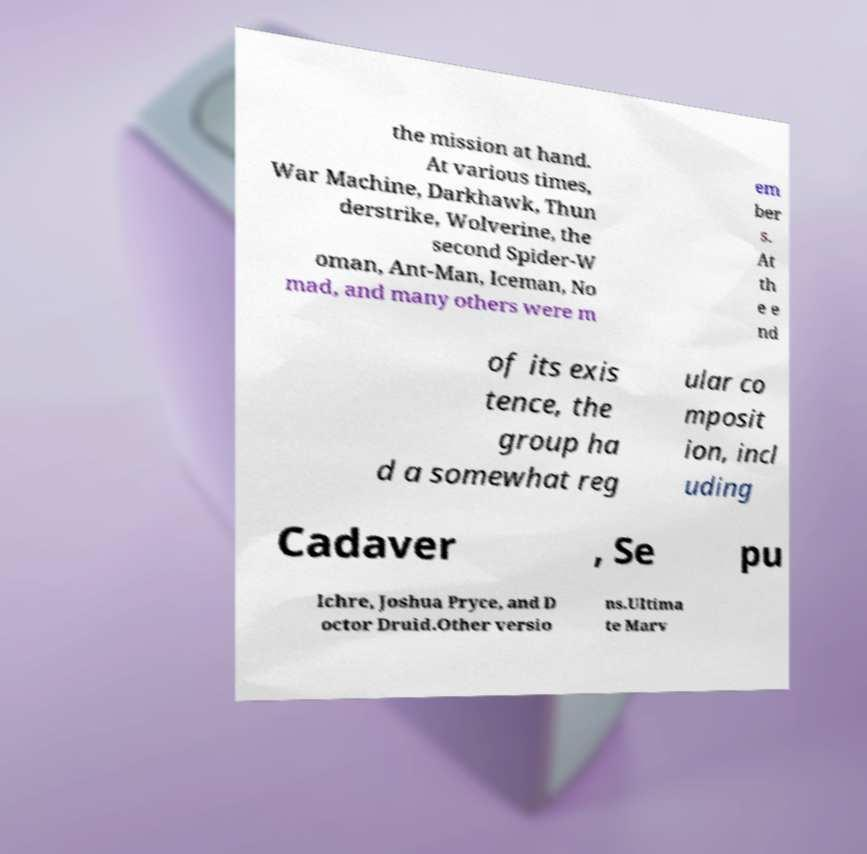I need the written content from this picture converted into text. Can you do that? the mission at hand. At various times, War Machine, Darkhawk, Thun derstrike, Wolverine, the second Spider-W oman, Ant-Man, Iceman, No mad, and many others were m em ber s. At th e e nd of its exis tence, the group ha d a somewhat reg ular co mposit ion, incl uding Cadaver , Se pu lchre, Joshua Pryce, and D octor Druid.Other versio ns.Ultima te Marv 